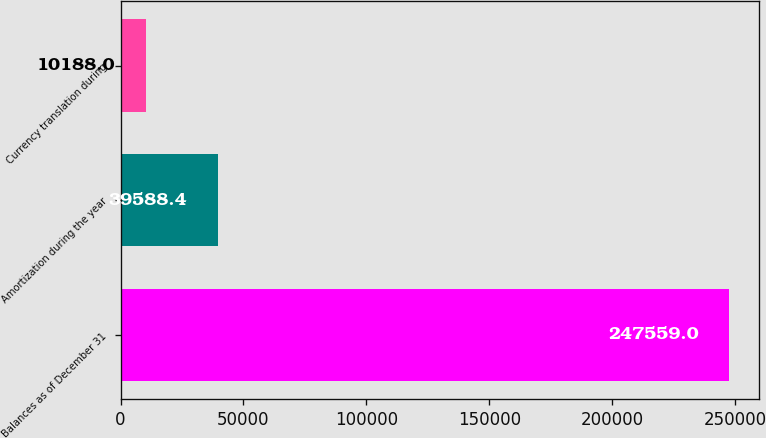<chart> <loc_0><loc_0><loc_500><loc_500><bar_chart><fcel>Balances as of December 31<fcel>Amortization during the year<fcel>Currency translation during<nl><fcel>247559<fcel>39588.4<fcel>10188<nl></chart> 